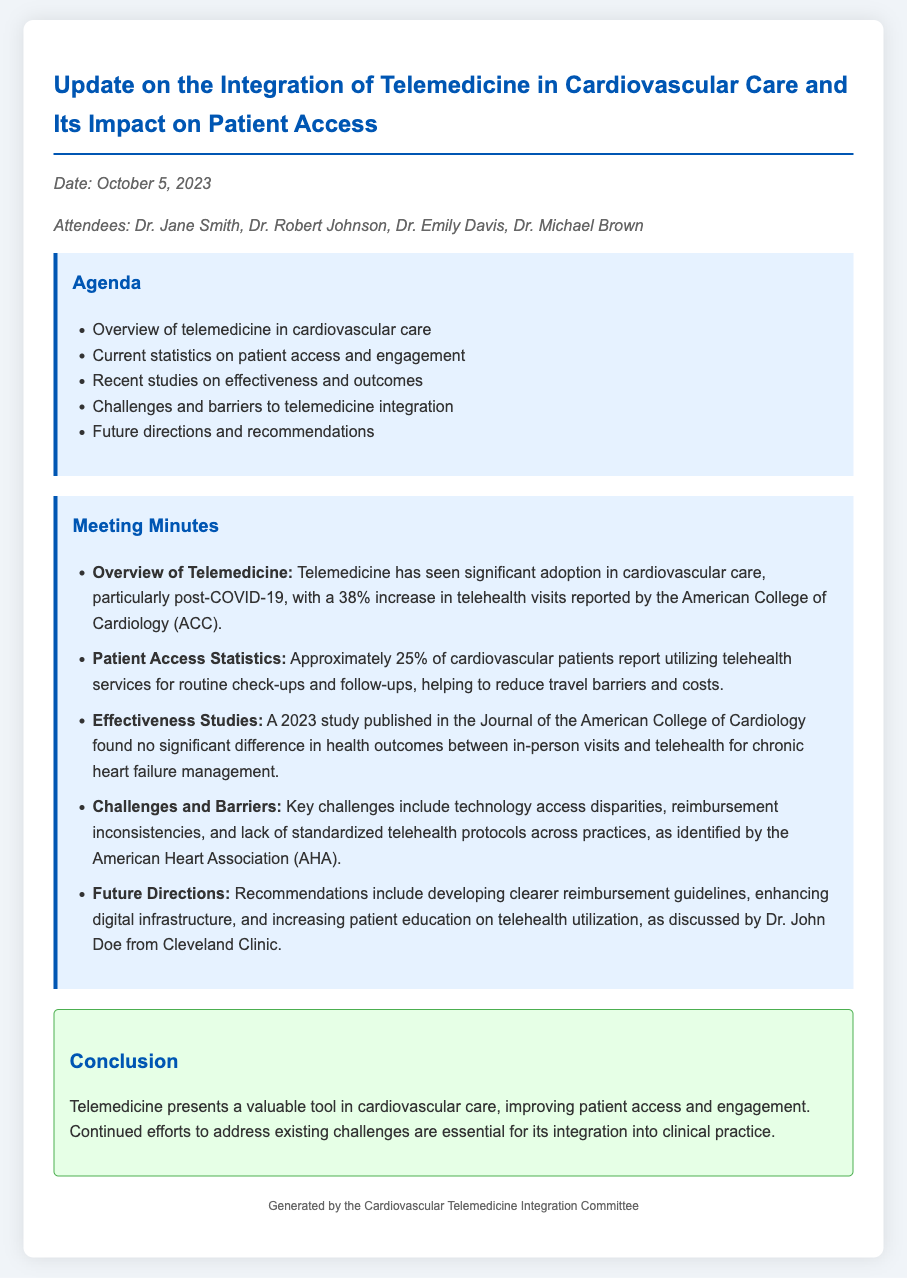What date was the meeting held? The date is explicitly mentioned in the document as October 5, 2023.
Answer: October 5, 2023 Who reported a 38% increase in telehealth visits? The document cites the American College of Cardiology (ACC) regarding the increase in telehealth visits.
Answer: American College of Cardiology What percentage of cardiovascular patients utilize telehealth services? The document specifies that approximately 25% of cardiovascular patients report utilizing telehealth services.
Answer: 25% What are key challenges to telemedicine integration mentioned? The document lists technology access disparities, reimbursement inconsistencies, and lack of standardized telehealth protocols as key challenges.
Answer: Technology access disparities, reimbursement inconsistencies, lack of standardized telehealth protocols What organization identified the challenges to telemedicine integration? The American Heart Association (AHA) is the organization that identified the challenges in the document.
Answer: American Heart Association What was the conclusion regarding telemedicine in cardiovascular care? The conclusion summarizes that telemedicine improves patient access and engagement while requiring continued efforts to address existing challenges.
Answer: Telemedicine improves patient access and engagement What study was referenced regarding effectiveness in chronic heart failure management? The document refers to a 2023 study published in the Journal of the American College of Cardiology.
Answer: Journal of the American College of Cardiology Who discussed future directions for telemedicine in the meeting? Dr. John Doe from Cleveland Clinic is mentioned as discussing future directions in the meeting.
Answer: Dr. John Doe from Cleveland Clinic What is the primary purpose of the meeting minutes document? The document serves to provide an update on the integration of telemedicine in cardiovascular care and its impact on patient access.
Answer: Update on the integration of telemedicine in cardiovascular care and its impact on patient access 